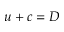<formula> <loc_0><loc_0><loc_500><loc_500>u + c = D</formula> 